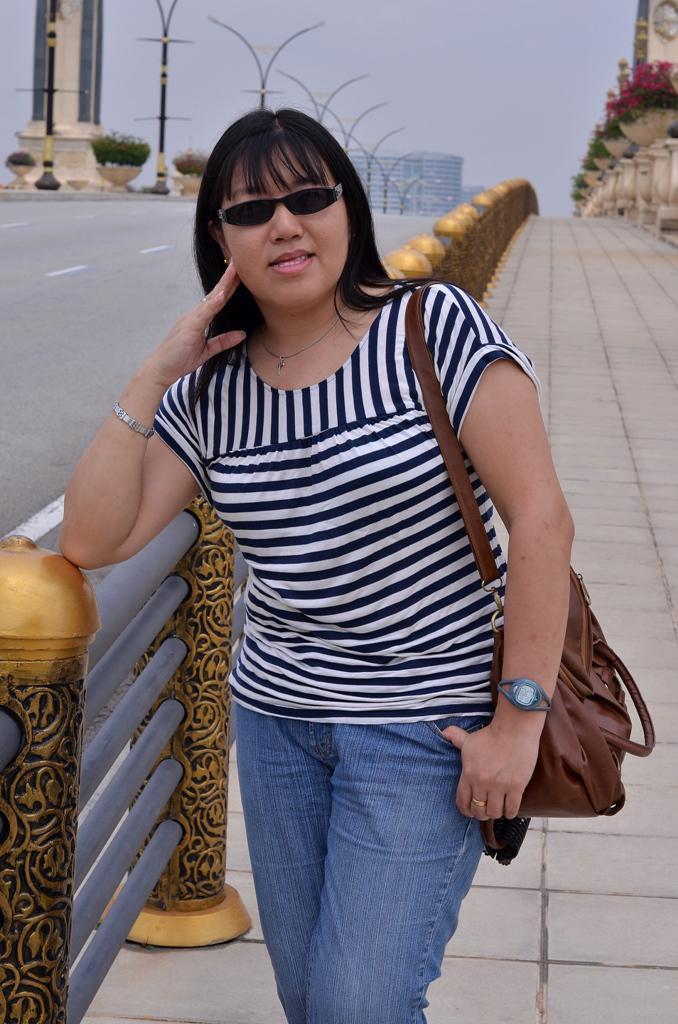In one or two sentences, can you explain what this image depicts? The woman in the middle of the picture wearing a white and black T-shirt and blue jeans is standing on the sideways. She's even wearing a brown bag and goggles. Beside her, we see an iron railing and the road. In the right top of the picture, there is a building. On the left corner of the picture, we see street lights and building. At the top of the picture, we see the sky. 